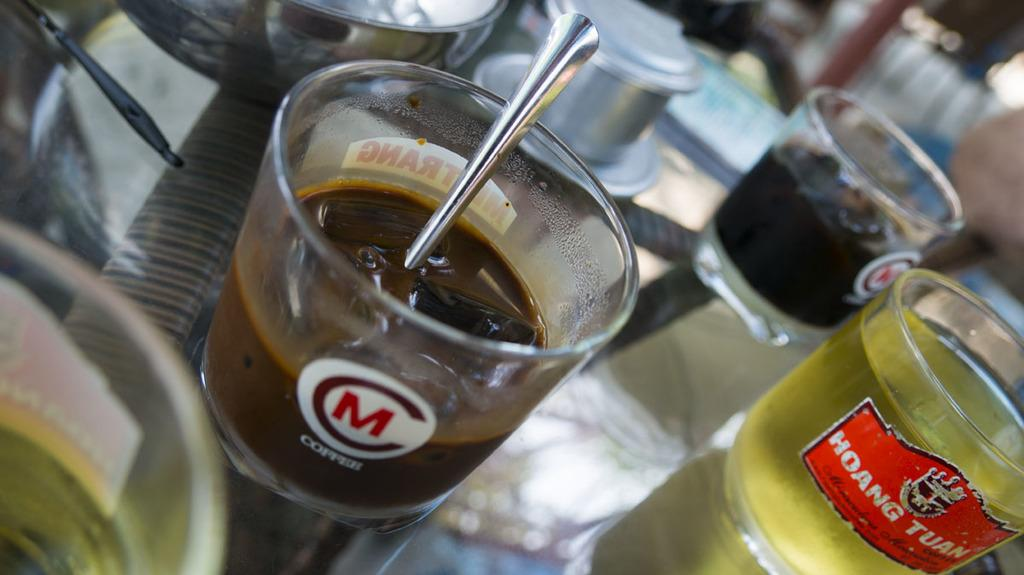<image>
Offer a succinct explanation of the picture presented. A glass with M Copper printed on the side. 